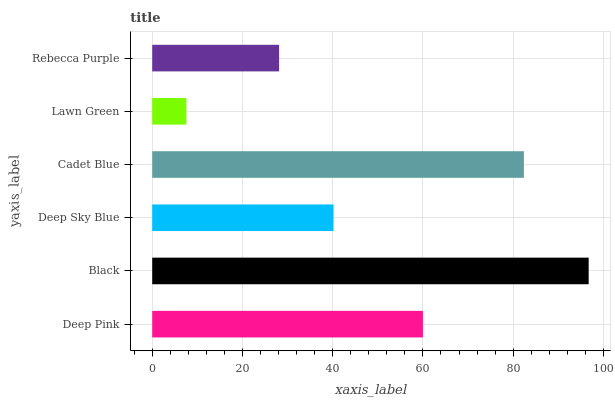Is Lawn Green the minimum?
Answer yes or no. Yes. Is Black the maximum?
Answer yes or no. Yes. Is Deep Sky Blue the minimum?
Answer yes or no. No. Is Deep Sky Blue the maximum?
Answer yes or no. No. Is Black greater than Deep Sky Blue?
Answer yes or no. Yes. Is Deep Sky Blue less than Black?
Answer yes or no. Yes. Is Deep Sky Blue greater than Black?
Answer yes or no. No. Is Black less than Deep Sky Blue?
Answer yes or no. No. Is Deep Pink the high median?
Answer yes or no. Yes. Is Deep Sky Blue the low median?
Answer yes or no. Yes. Is Deep Sky Blue the high median?
Answer yes or no. No. Is Rebecca Purple the low median?
Answer yes or no. No. 